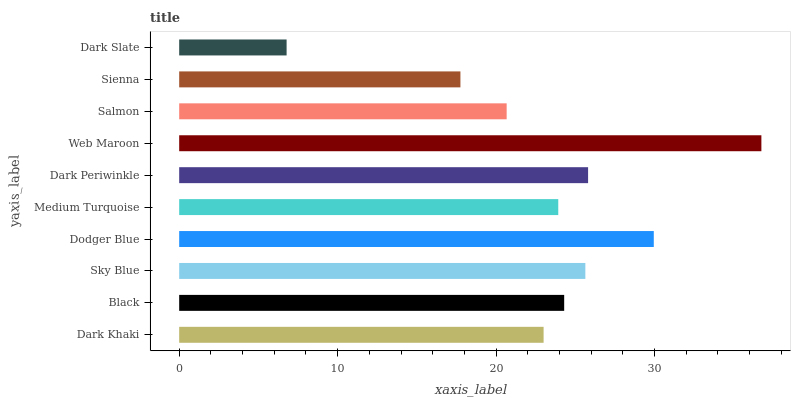Is Dark Slate the minimum?
Answer yes or no. Yes. Is Web Maroon the maximum?
Answer yes or no. Yes. Is Black the minimum?
Answer yes or no. No. Is Black the maximum?
Answer yes or no. No. Is Black greater than Dark Khaki?
Answer yes or no. Yes. Is Dark Khaki less than Black?
Answer yes or no. Yes. Is Dark Khaki greater than Black?
Answer yes or no. No. Is Black less than Dark Khaki?
Answer yes or no. No. Is Black the high median?
Answer yes or no. Yes. Is Medium Turquoise the low median?
Answer yes or no. Yes. Is Dark Periwinkle the high median?
Answer yes or no. No. Is Dark Khaki the low median?
Answer yes or no. No. 